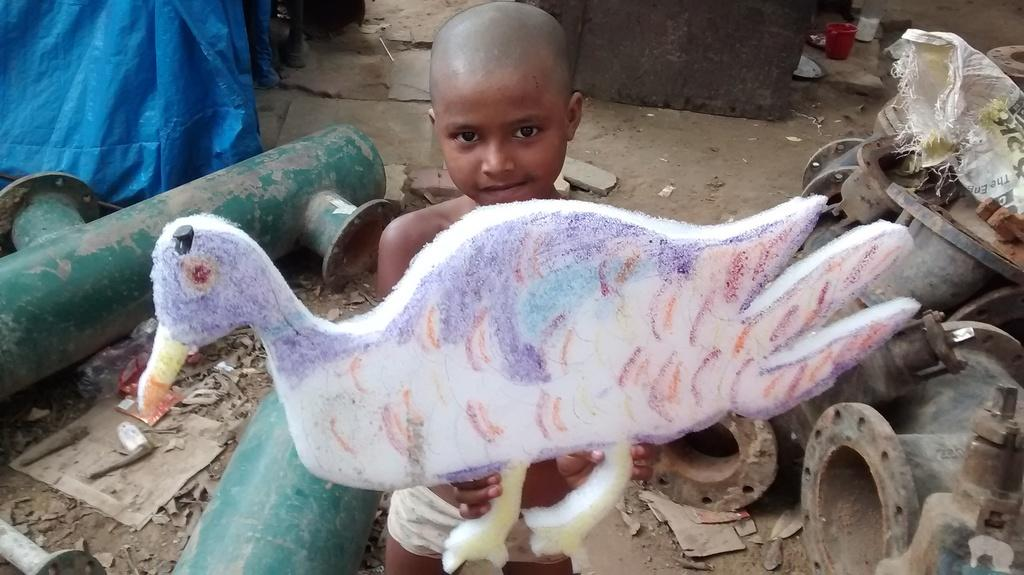What type of objects can be seen in the image related to water? There are water pipes in the image. What toy is present in the image? There is a toy duck in the image. What is the boy in the image doing? The boy is sitting in the image. What type of equipment can be seen in the image related to iron? There are ironic equipments in the image. What type of wool is being spun by the flame in the image? There is no wool or flame present in the image. 